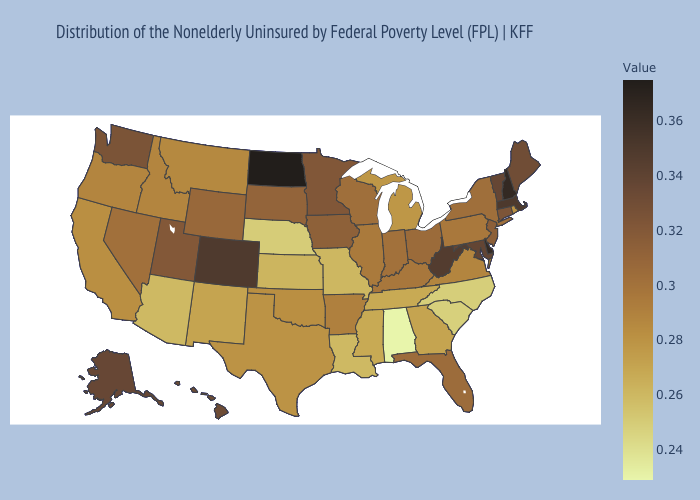Among the states that border New Mexico , does Colorado have the highest value?
Write a very short answer. Yes. Which states have the lowest value in the USA?
Write a very short answer. Alabama. Does the map have missing data?
Concise answer only. No. Does the map have missing data?
Keep it brief. No. Which states have the lowest value in the USA?
Concise answer only. Alabama. Does North Dakota have the highest value in the USA?
Answer briefly. Yes. Which states have the lowest value in the South?
Answer briefly. Alabama. 